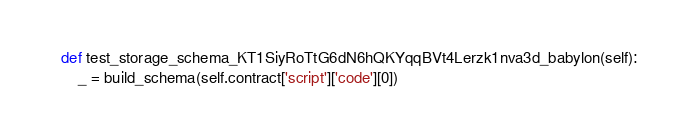Convert code to text. <code><loc_0><loc_0><loc_500><loc_500><_Python_>    def test_storage_schema_KT1SiyRoTtG6dN6hQKYqqBVt4Lerzk1nva3d_babylon(self):
        _ = build_schema(self.contract['script']['code'][0])
</code> 